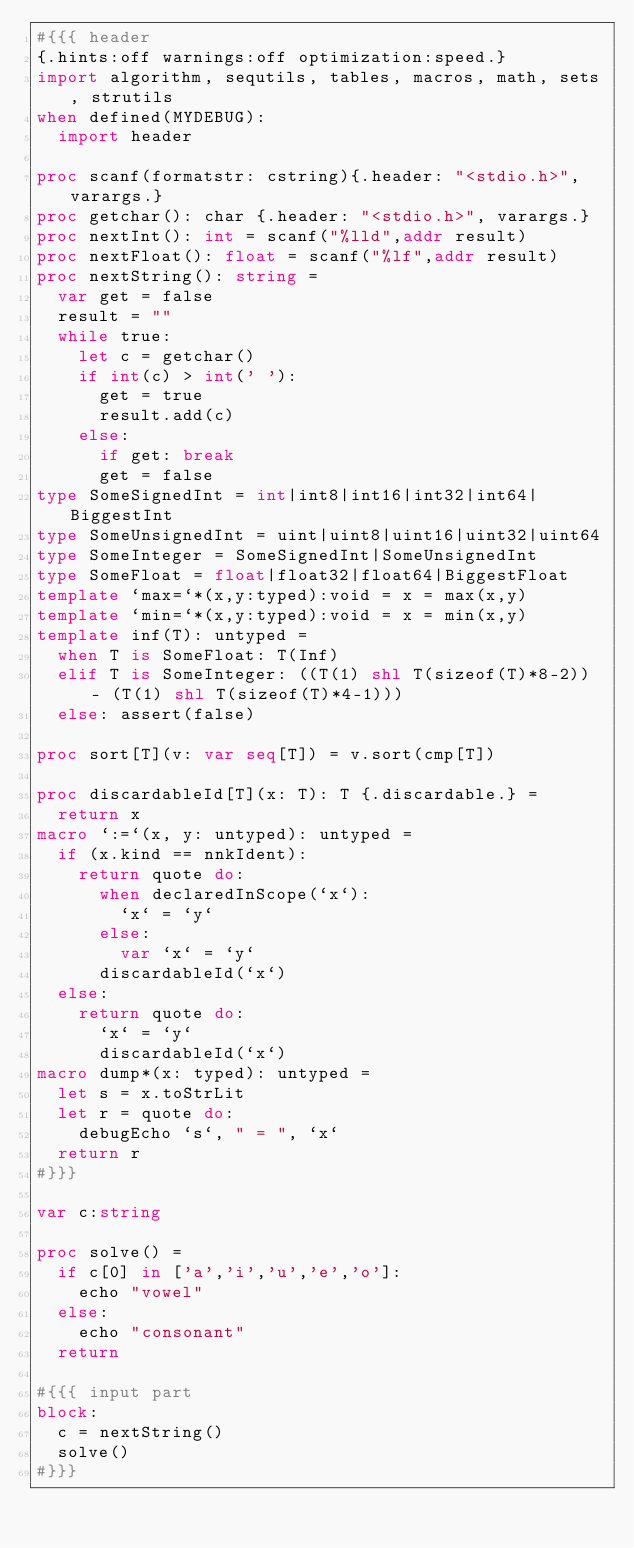<code> <loc_0><loc_0><loc_500><loc_500><_Nim_>#{{{ header
{.hints:off warnings:off optimization:speed.}
import algorithm, sequtils, tables, macros, math, sets, strutils
when defined(MYDEBUG):
  import header

proc scanf(formatstr: cstring){.header: "<stdio.h>", varargs.}
proc getchar(): char {.header: "<stdio.h>", varargs.}
proc nextInt(): int = scanf("%lld",addr result)
proc nextFloat(): float = scanf("%lf",addr result)
proc nextString(): string =
  var get = false
  result = ""
  while true:
    let c = getchar()
    if int(c) > int(' '):
      get = true
      result.add(c)
    else:
      if get: break
      get = false
type SomeSignedInt = int|int8|int16|int32|int64|BiggestInt
type SomeUnsignedInt = uint|uint8|uint16|uint32|uint64
type SomeInteger = SomeSignedInt|SomeUnsignedInt
type SomeFloat = float|float32|float64|BiggestFloat
template `max=`*(x,y:typed):void = x = max(x,y)
template `min=`*(x,y:typed):void = x = min(x,y)
template inf(T): untyped = 
  when T is SomeFloat: T(Inf)
  elif T is SomeInteger: ((T(1) shl T(sizeof(T)*8-2)) - (T(1) shl T(sizeof(T)*4-1)))
  else: assert(false)

proc sort[T](v: var seq[T]) = v.sort(cmp[T])

proc discardableId[T](x: T): T {.discardable.} =
  return x
macro `:=`(x, y: untyped): untyped =
  if (x.kind == nnkIdent):
    return quote do:
      when declaredInScope(`x`):
        `x` = `y`
      else:
        var `x` = `y`
      discardableId(`x`)
  else:
    return quote do:
      `x` = `y`
      discardableId(`x`)
macro dump*(x: typed): untyped =
  let s = x.toStrLit
  let r = quote do:
    debugEcho `s`, " = ", `x`
  return r
#}}}

var c:string

proc solve() =
  if c[0] in ['a','i','u','e','o']:
    echo "vowel"
  else:
    echo "consonant"
  return

#{{{ input part
block:
  c = nextString()
  solve()
#}}}
</code> 